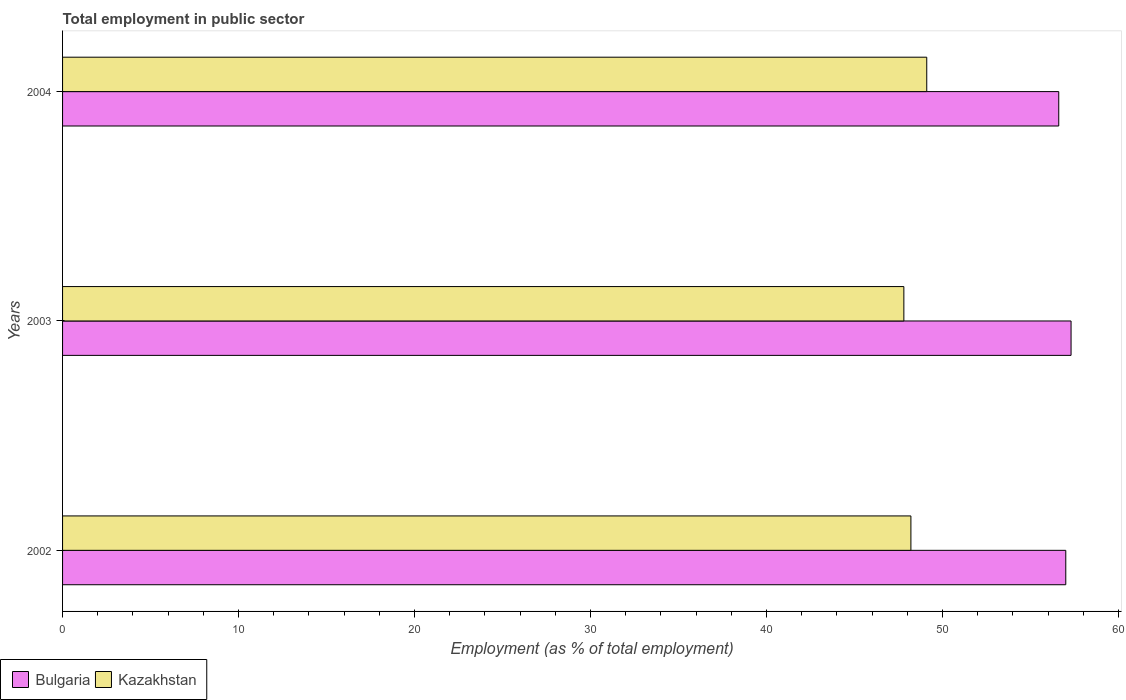In how many cases, is the number of bars for a given year not equal to the number of legend labels?
Your answer should be compact. 0. Across all years, what is the maximum employment in public sector in Kazakhstan?
Provide a short and direct response. 49.1. Across all years, what is the minimum employment in public sector in Kazakhstan?
Keep it short and to the point. 47.8. In which year was the employment in public sector in Bulgaria maximum?
Your response must be concise. 2003. In which year was the employment in public sector in Kazakhstan minimum?
Make the answer very short. 2003. What is the total employment in public sector in Kazakhstan in the graph?
Ensure brevity in your answer.  145.1. What is the difference between the employment in public sector in Kazakhstan in 2003 and that in 2004?
Your answer should be compact. -1.3. What is the difference between the employment in public sector in Bulgaria in 2003 and the employment in public sector in Kazakhstan in 2002?
Give a very brief answer. 9.1. What is the average employment in public sector in Kazakhstan per year?
Ensure brevity in your answer.  48.37. What is the ratio of the employment in public sector in Kazakhstan in 2003 to that in 2004?
Your answer should be very brief. 0.97. Is the employment in public sector in Bulgaria in 2003 less than that in 2004?
Give a very brief answer. No. Is the difference between the employment in public sector in Bulgaria in 2003 and 2004 greater than the difference between the employment in public sector in Kazakhstan in 2003 and 2004?
Make the answer very short. Yes. What is the difference between the highest and the second highest employment in public sector in Bulgaria?
Offer a very short reply. 0.3. What is the difference between the highest and the lowest employment in public sector in Kazakhstan?
Ensure brevity in your answer.  1.3. Is the sum of the employment in public sector in Kazakhstan in 2002 and 2003 greater than the maximum employment in public sector in Bulgaria across all years?
Your answer should be very brief. Yes. What does the 1st bar from the top in 2003 represents?
Your response must be concise. Kazakhstan. What does the 2nd bar from the bottom in 2002 represents?
Keep it short and to the point. Kazakhstan. What is the difference between two consecutive major ticks on the X-axis?
Give a very brief answer. 10. Are the values on the major ticks of X-axis written in scientific E-notation?
Your response must be concise. No. Where does the legend appear in the graph?
Offer a very short reply. Bottom left. How many legend labels are there?
Make the answer very short. 2. What is the title of the graph?
Provide a short and direct response. Total employment in public sector. What is the label or title of the X-axis?
Provide a short and direct response. Employment (as % of total employment). What is the label or title of the Y-axis?
Offer a terse response. Years. What is the Employment (as % of total employment) in Kazakhstan in 2002?
Your answer should be very brief. 48.2. What is the Employment (as % of total employment) in Bulgaria in 2003?
Offer a terse response. 57.3. What is the Employment (as % of total employment) of Kazakhstan in 2003?
Your answer should be compact. 47.8. What is the Employment (as % of total employment) in Bulgaria in 2004?
Give a very brief answer. 56.6. What is the Employment (as % of total employment) of Kazakhstan in 2004?
Provide a short and direct response. 49.1. Across all years, what is the maximum Employment (as % of total employment) of Bulgaria?
Offer a very short reply. 57.3. Across all years, what is the maximum Employment (as % of total employment) in Kazakhstan?
Your answer should be compact. 49.1. Across all years, what is the minimum Employment (as % of total employment) of Bulgaria?
Offer a very short reply. 56.6. Across all years, what is the minimum Employment (as % of total employment) in Kazakhstan?
Provide a short and direct response. 47.8. What is the total Employment (as % of total employment) of Bulgaria in the graph?
Keep it short and to the point. 170.9. What is the total Employment (as % of total employment) in Kazakhstan in the graph?
Give a very brief answer. 145.1. What is the difference between the Employment (as % of total employment) of Bulgaria in 2002 and that in 2003?
Provide a short and direct response. -0.3. What is the difference between the Employment (as % of total employment) in Kazakhstan in 2002 and that in 2003?
Keep it short and to the point. 0.4. What is the difference between the Employment (as % of total employment) in Bulgaria in 2002 and that in 2004?
Your answer should be very brief. 0.4. What is the difference between the Employment (as % of total employment) in Kazakhstan in 2003 and that in 2004?
Ensure brevity in your answer.  -1.3. What is the difference between the Employment (as % of total employment) in Bulgaria in 2002 and the Employment (as % of total employment) in Kazakhstan in 2003?
Your answer should be very brief. 9.2. What is the average Employment (as % of total employment) in Bulgaria per year?
Your answer should be compact. 56.97. What is the average Employment (as % of total employment) of Kazakhstan per year?
Provide a succinct answer. 48.37. In the year 2003, what is the difference between the Employment (as % of total employment) in Bulgaria and Employment (as % of total employment) in Kazakhstan?
Offer a very short reply. 9.5. In the year 2004, what is the difference between the Employment (as % of total employment) of Bulgaria and Employment (as % of total employment) of Kazakhstan?
Your answer should be very brief. 7.5. What is the ratio of the Employment (as % of total employment) of Bulgaria in 2002 to that in 2003?
Offer a very short reply. 0.99. What is the ratio of the Employment (as % of total employment) in Kazakhstan in 2002 to that in 2003?
Keep it short and to the point. 1.01. What is the ratio of the Employment (as % of total employment) of Bulgaria in 2002 to that in 2004?
Offer a very short reply. 1.01. What is the ratio of the Employment (as % of total employment) of Kazakhstan in 2002 to that in 2004?
Provide a succinct answer. 0.98. What is the ratio of the Employment (as % of total employment) in Bulgaria in 2003 to that in 2004?
Offer a terse response. 1.01. What is the ratio of the Employment (as % of total employment) in Kazakhstan in 2003 to that in 2004?
Offer a very short reply. 0.97. What is the difference between the highest and the second highest Employment (as % of total employment) of Bulgaria?
Your answer should be compact. 0.3. What is the difference between the highest and the lowest Employment (as % of total employment) in Bulgaria?
Provide a short and direct response. 0.7. 